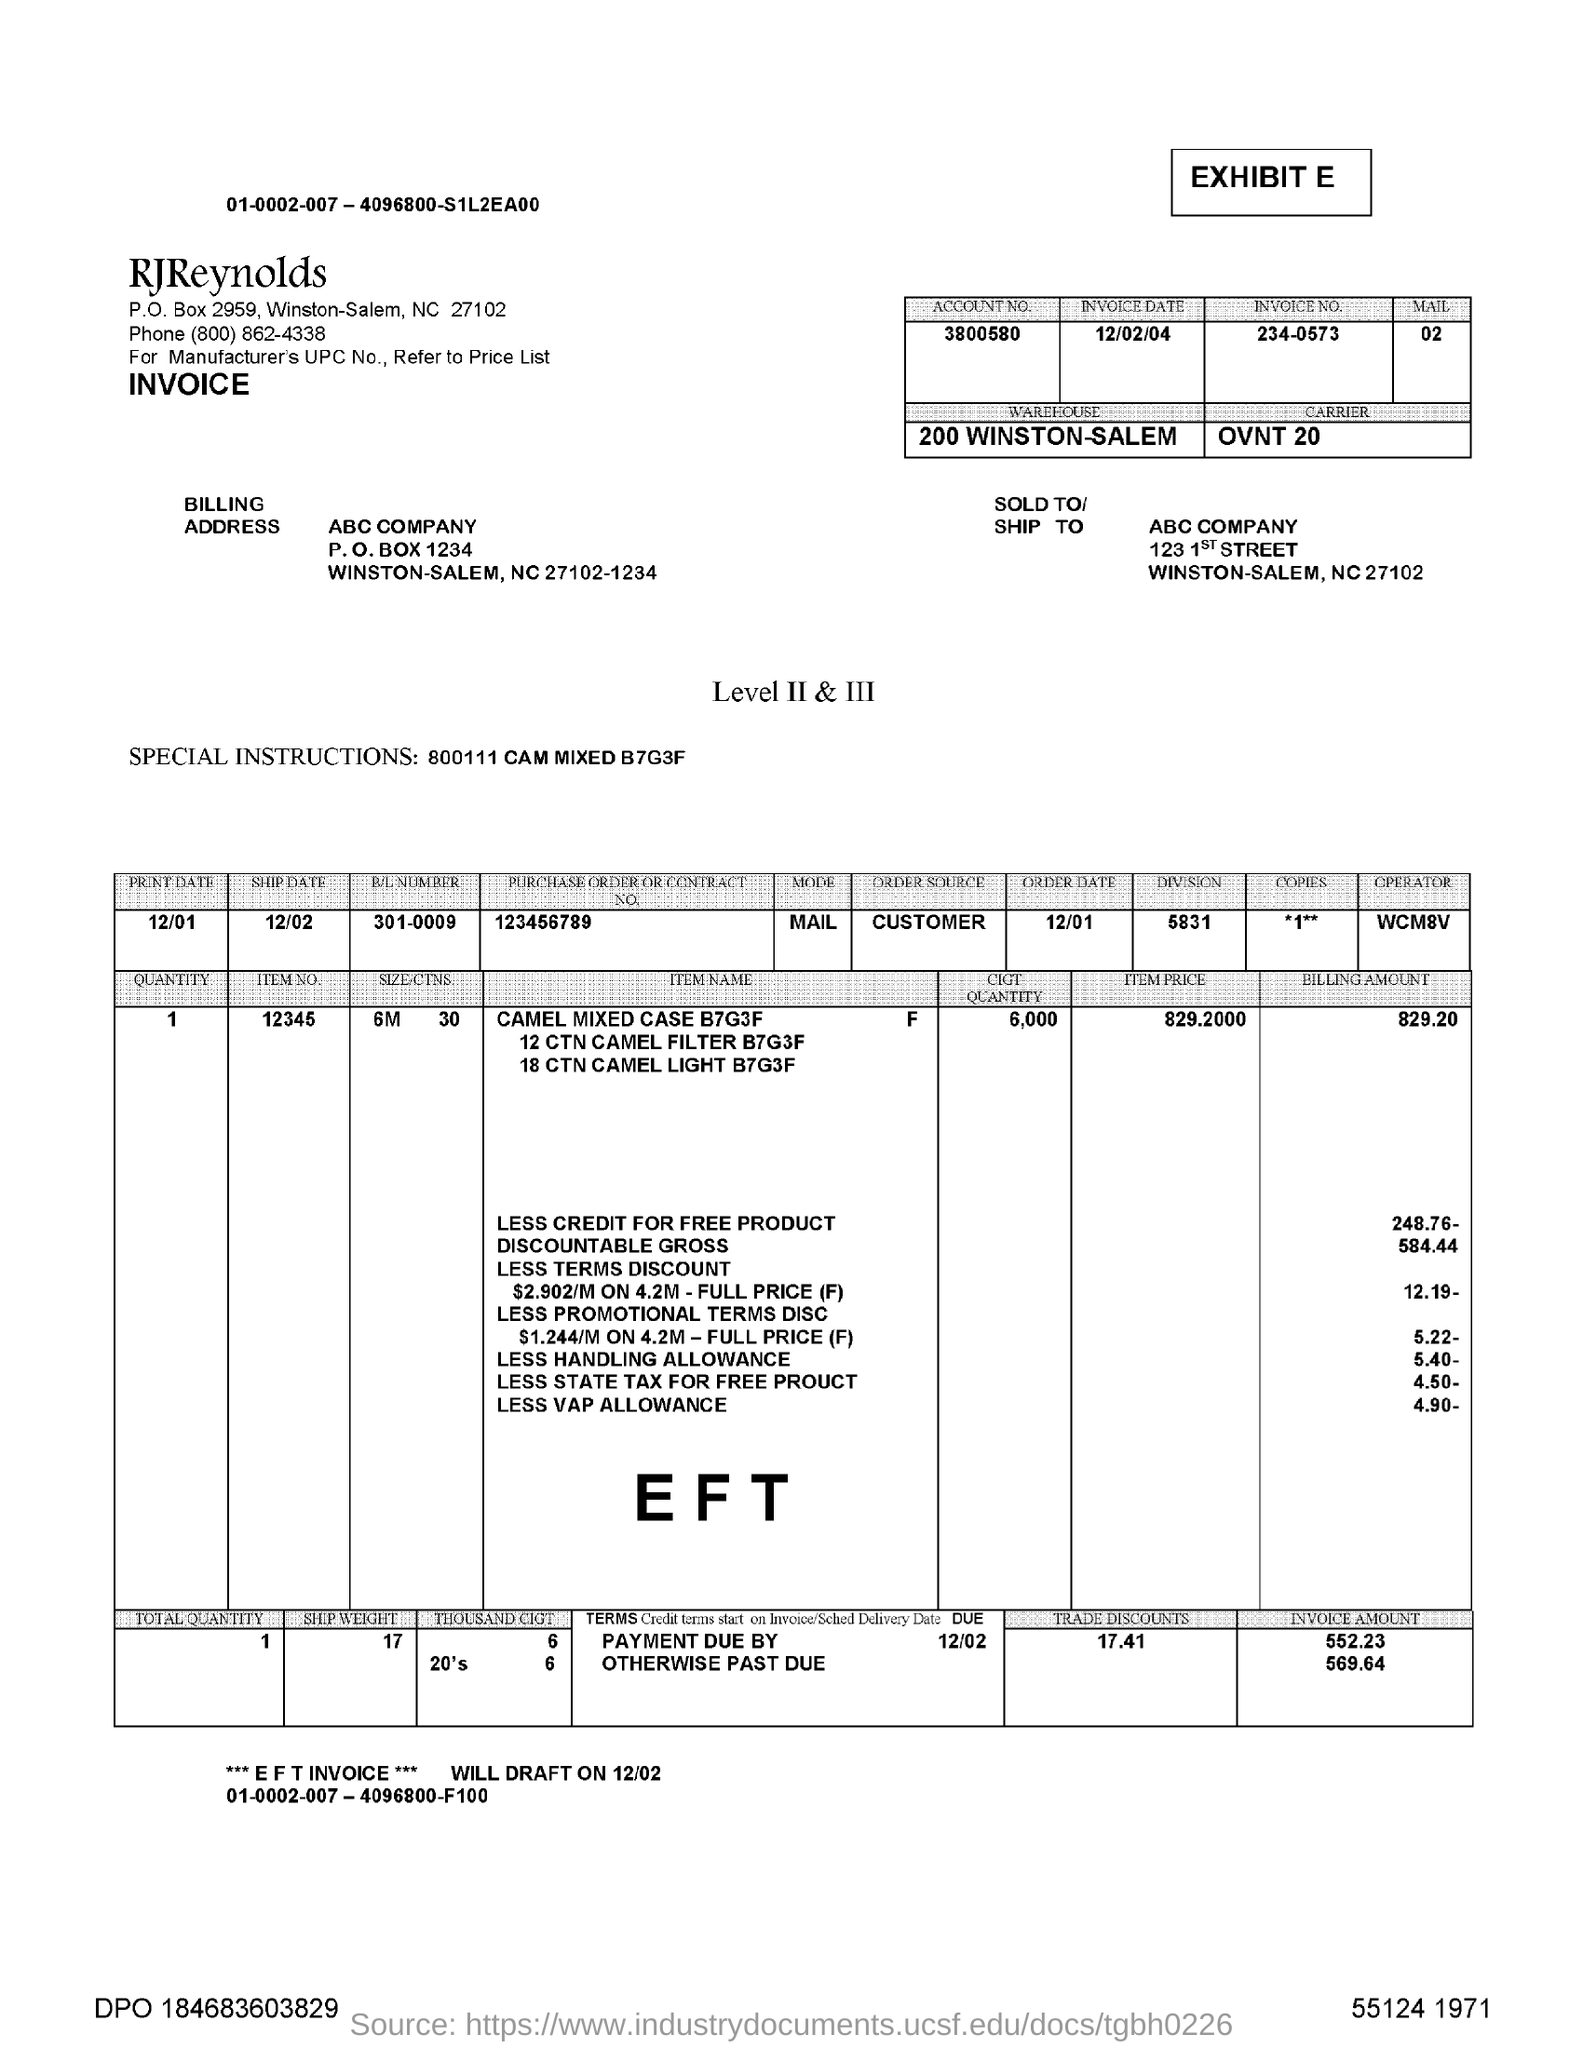Mention a couple of crucial points in this snapshot. The purchase order or contract number of the product is 123456789... This letter is addressed to ABC company. The invoice number is 234-0573. Could you please provide the account number, which is 3800580...? The item has a price of 829.2000...," is the item price. 